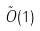Convert formula to latex. <formula><loc_0><loc_0><loc_500><loc_500>\tilde { O } ( 1 )</formula> 